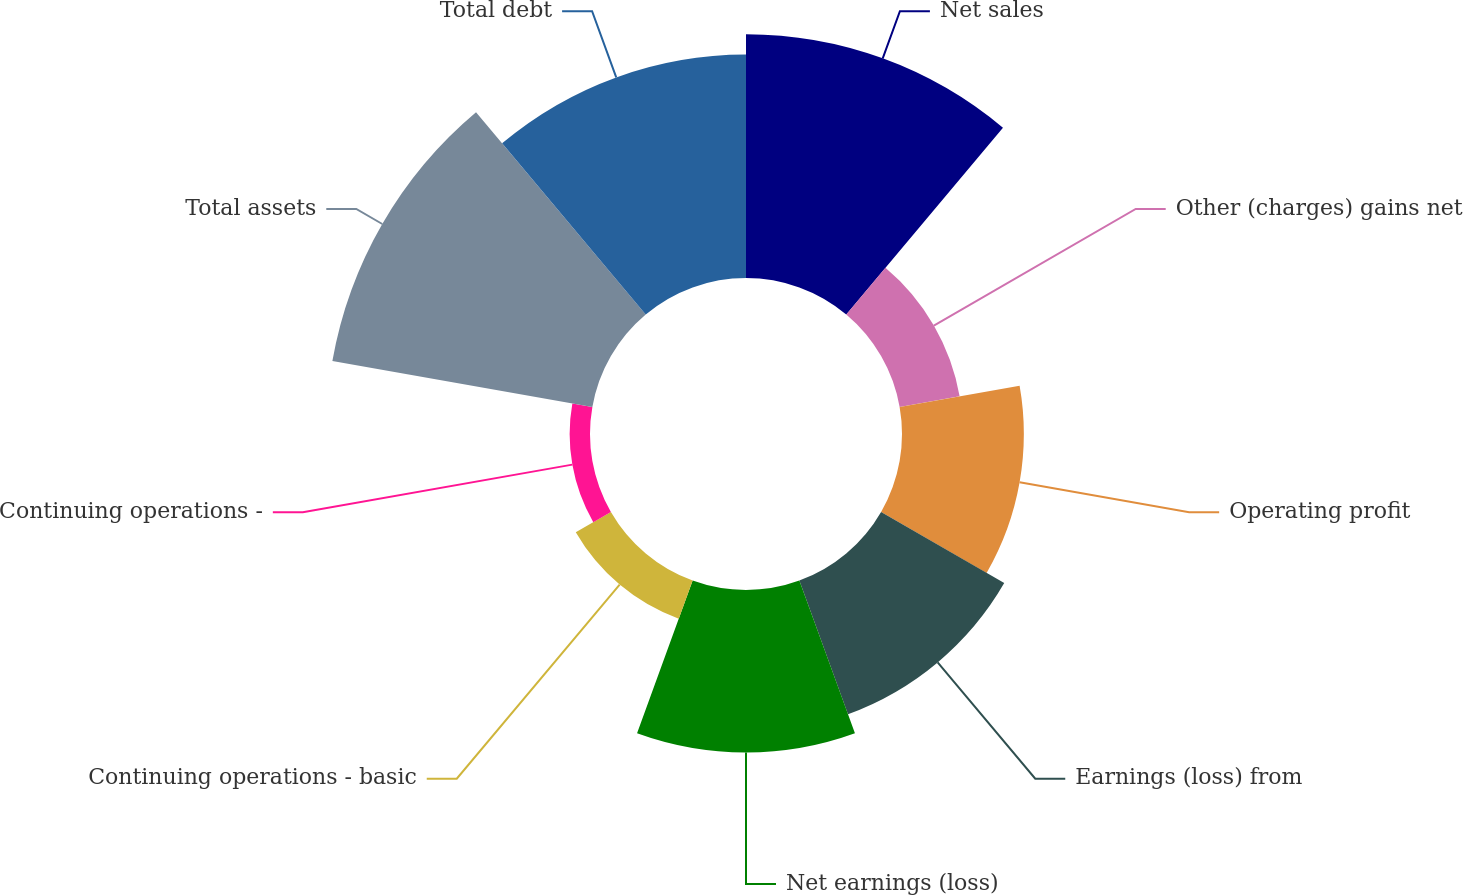<chart> <loc_0><loc_0><loc_500><loc_500><pie_chart><fcel>Net sales<fcel>Other (charges) gains net<fcel>Operating profit<fcel>Earnings (loss) from<fcel>Net earnings (loss)<fcel>Continuing operations - basic<fcel>Continuing operations -<fcel>Total assets<fcel>Total debt<nl><fcel>19.05%<fcel>4.76%<fcel>9.52%<fcel>11.11%<fcel>12.7%<fcel>3.17%<fcel>1.59%<fcel>20.63%<fcel>17.46%<nl></chart> 